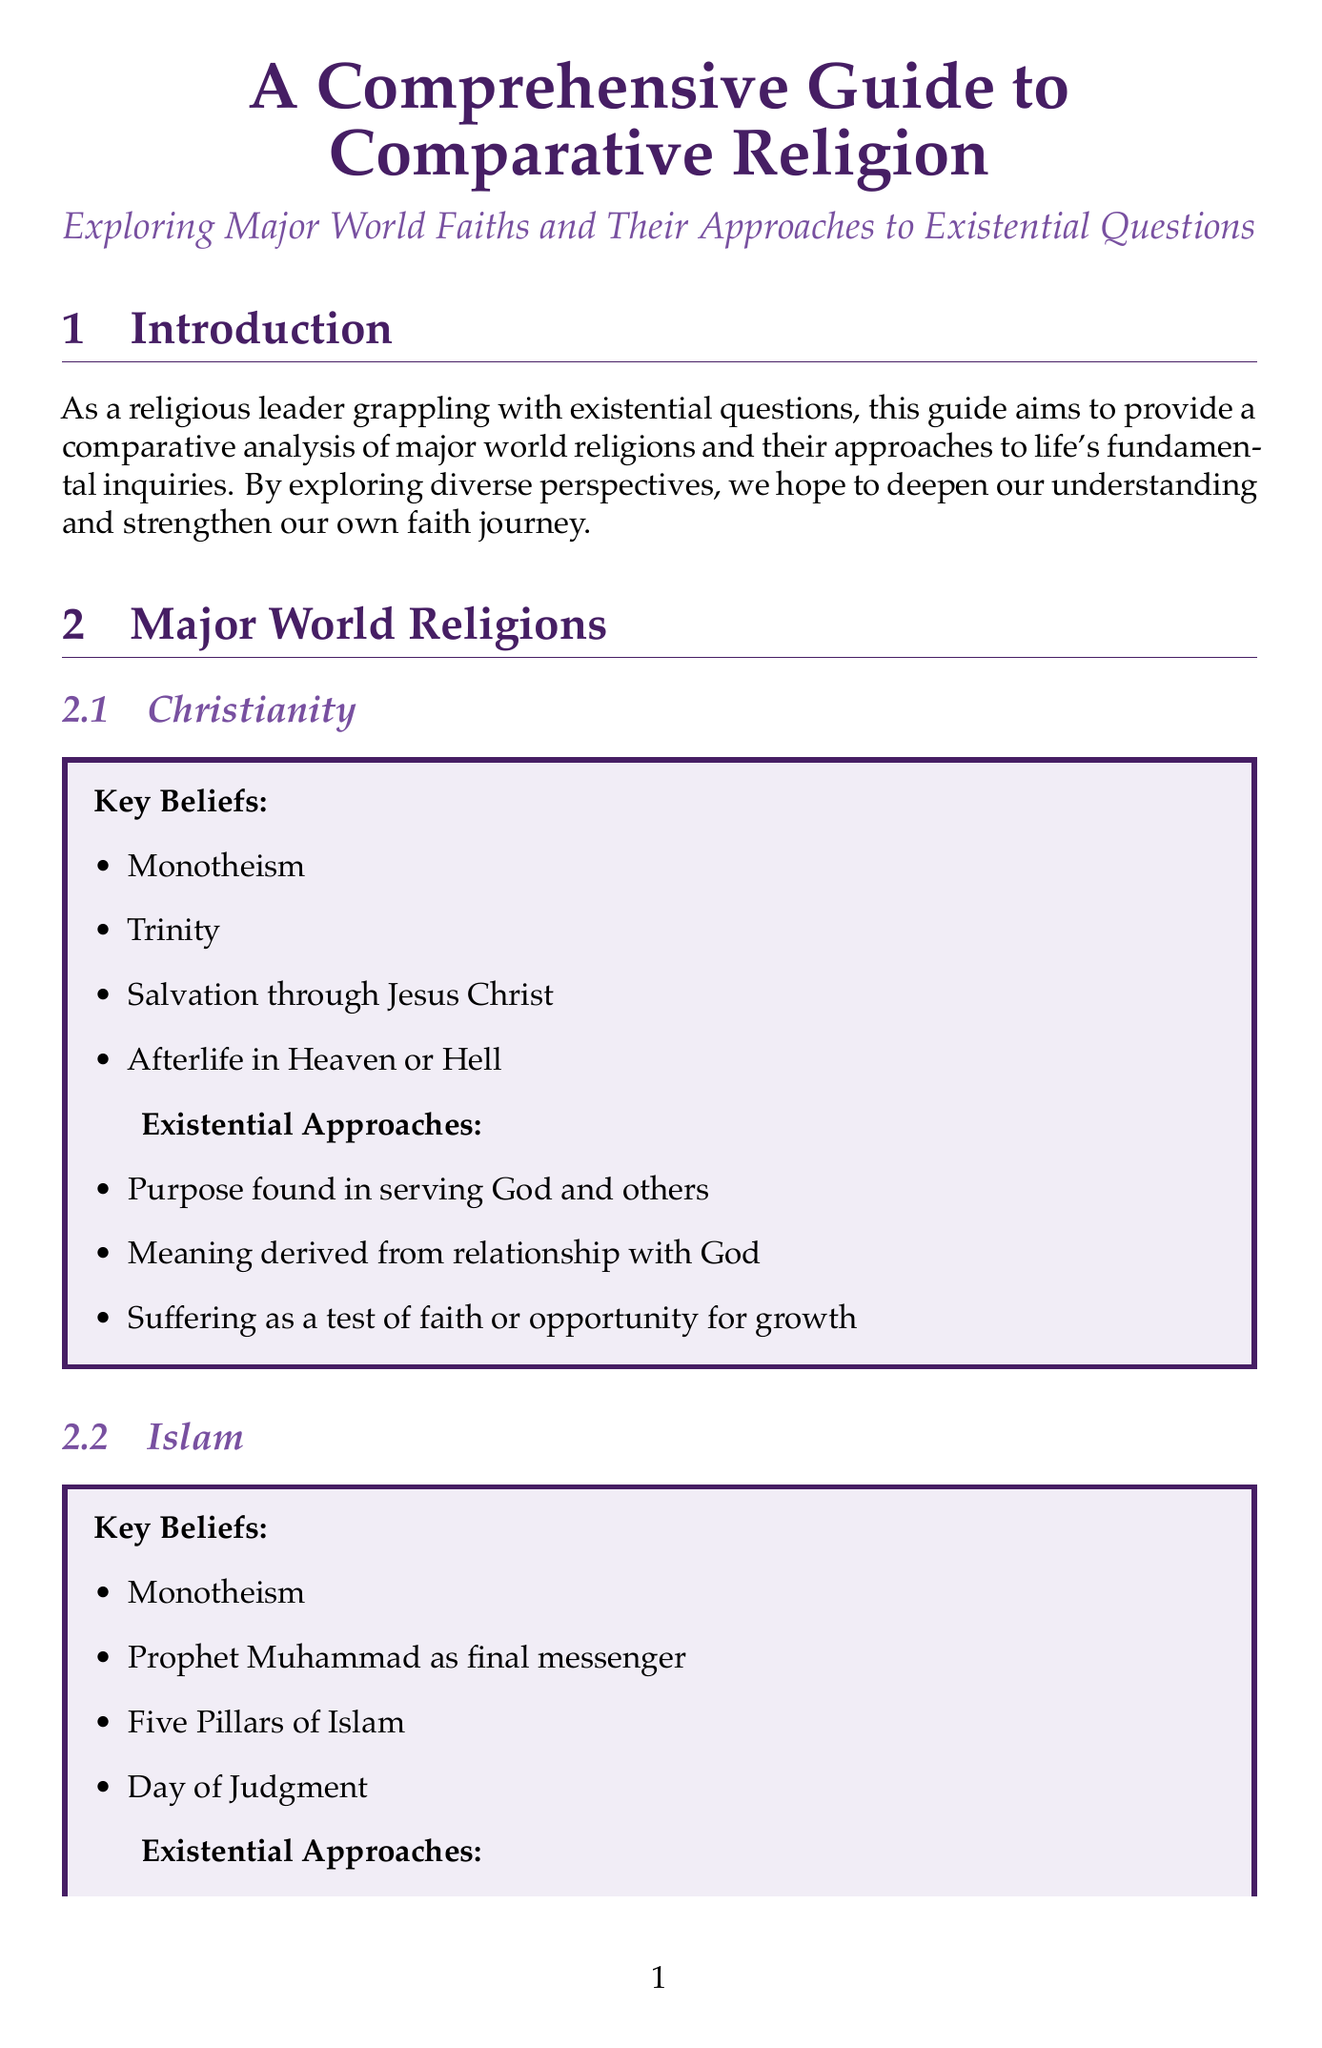What is the title of the guide? The title is clearly stated at the beginning of the document, providing the main focus of the content.
Answer: A Comprehensive Guide to Comparative Religion How many major world religions are discussed? The document lists five major world religions in the "Major World Religions" section.
Answer: Five What is one key belief in Buddhism? The section on Buddhism includes key beliefs, one of which is mentioned.
Answer: Four Noble Truths What purpose is found in serving God according to Christianity? This purpose is stated under "Existential Approaches" for Christianity in the document.
Answer: Serving God and others Which author wrote "God Is Not One"? The document lists resources for further study, including the author of the book.
Answer: Stephen Prothero What do different faiths address in the section titled "Purpose and Meaning of Life"? This section is focused on how various religions understand purpose and meaning, which is clearly outlined.
Answer: Why we exist and what gives life meaning What does Judaism see suffering as? The document states suffering in Judaism under "Existential Approaches," indicating its significance within the faith.
Answer: A challenge to faith and opportunity for growth What is emphasized in the "Interfaith Dialogue" section? This section discusses the importance of dialogue between different faith traditions, providing insight into the document's intent.
Answer: Common ground and mutual understanding 